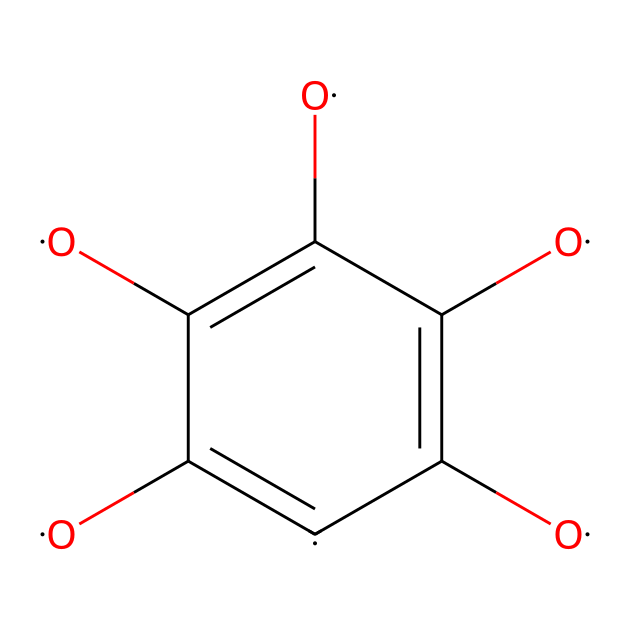how many carbon atoms are in the structure? By analyzing the SMILES representation, we count the carbon atoms labeled as [C]. There are six [C] atoms in total.
Answer: six how many oxygen atoms are present? In the SMILES representation, we look for instances of [O]. There are four instances of [O], indicating the presence of four oxygen atoms.
Answer: four what type of chemical bonding is prominent in this compound? The SMILES representation indicates multiple double bonds between carbon atoms and between carbon and oxygen, highlighting the presence of covalent bonds.
Answer: covalent what functional groups can be identified in this compound? The structure shows hydroxyl groups (due to the presence of -OH from [O] single bonds) and carbonyl groups (from the carbon double bonds with [O]), indicating that the chemical contains both hydroxyl and carbonyl functional groups.
Answer: hydroxyl and carbonyl how does the presence of functional groups impact water filtration efficiency? The presence of hydroxyl groups enhances the hydrophilicity of graphene oxide, improving adsorption of water contaminants. The ability of these functional groups to interact with water increases purification efficiency.
Answer: improves adsorption why is graphene oxide useful in water filtration applications? Graphene oxide has high surface area and functional groups that facilitate the adsorption of pollutants. These characteristics allow for effective filtration, making it favorable for use in water purification systems.
Answer: effective filtration 